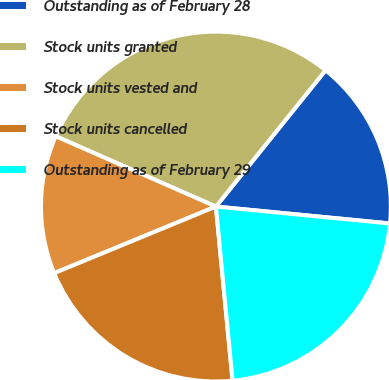<chart> <loc_0><loc_0><loc_500><loc_500><pie_chart><fcel>Outstanding as of February 28<fcel>Stock units granted<fcel>Stock units vested and<fcel>Stock units cancelled<fcel>Outstanding as of February 29<nl><fcel>15.76%<fcel>29.2%<fcel>12.8%<fcel>20.3%<fcel>21.94%<nl></chart> 